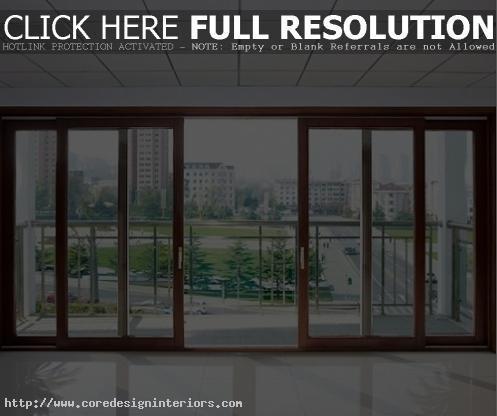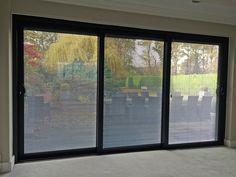The first image is the image on the left, the second image is the image on the right. Evaluate the accuracy of this statement regarding the images: "The doors in the image on the right open to a grassy area.". Is it true? Answer yes or no. No. 